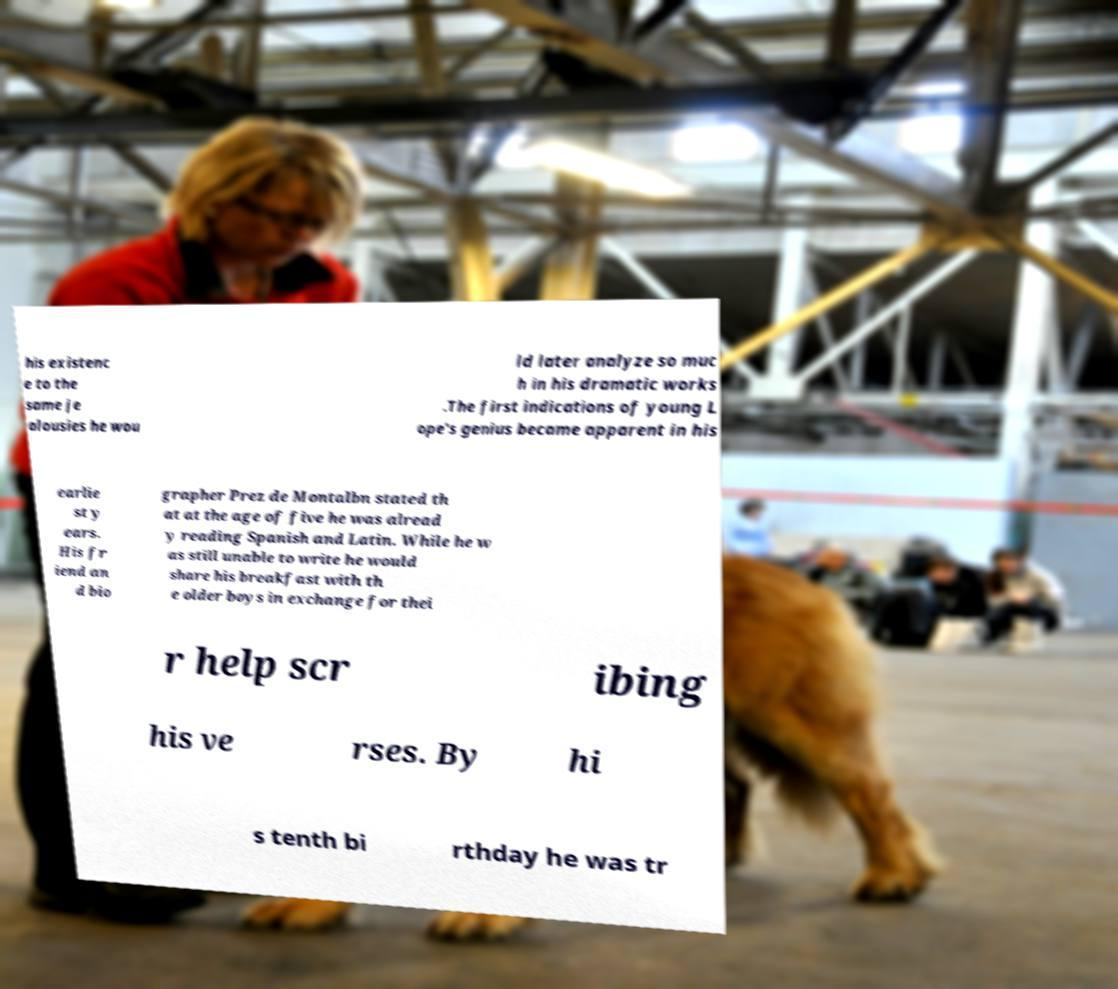Can you accurately transcribe the text from the provided image for me? his existenc e to the same je alousies he wou ld later analyze so muc h in his dramatic works .The first indications of young L ope's genius became apparent in his earlie st y ears. His fr iend an d bio grapher Prez de Montalbn stated th at at the age of five he was alread y reading Spanish and Latin. While he w as still unable to write he would share his breakfast with th e older boys in exchange for thei r help scr ibing his ve rses. By hi s tenth bi rthday he was tr 